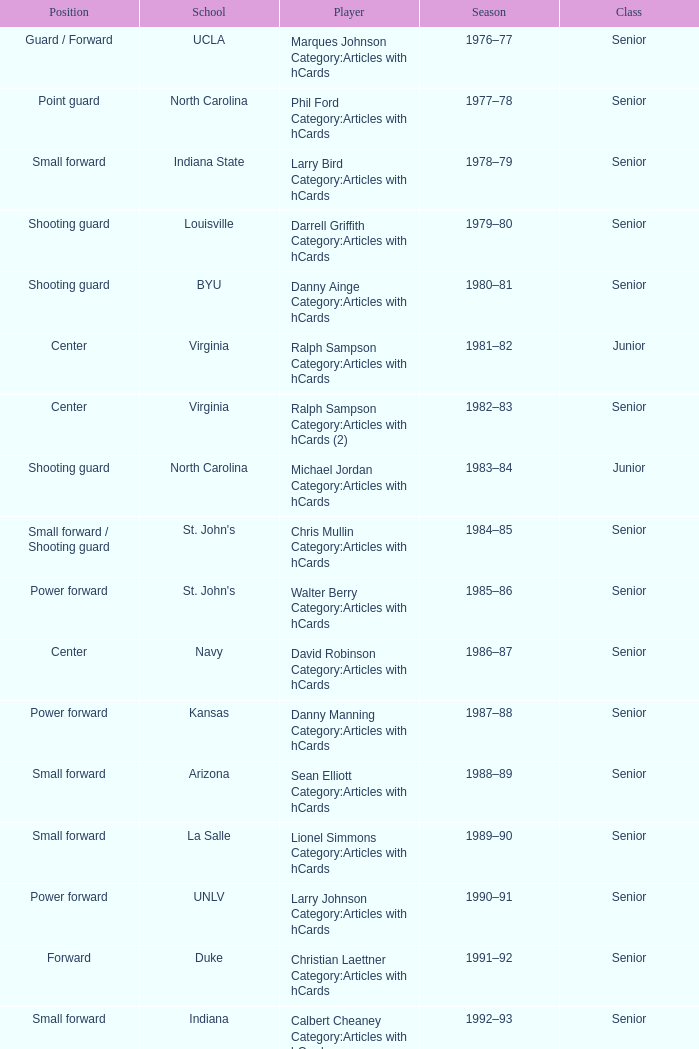Name the position for indiana state Small forward. 